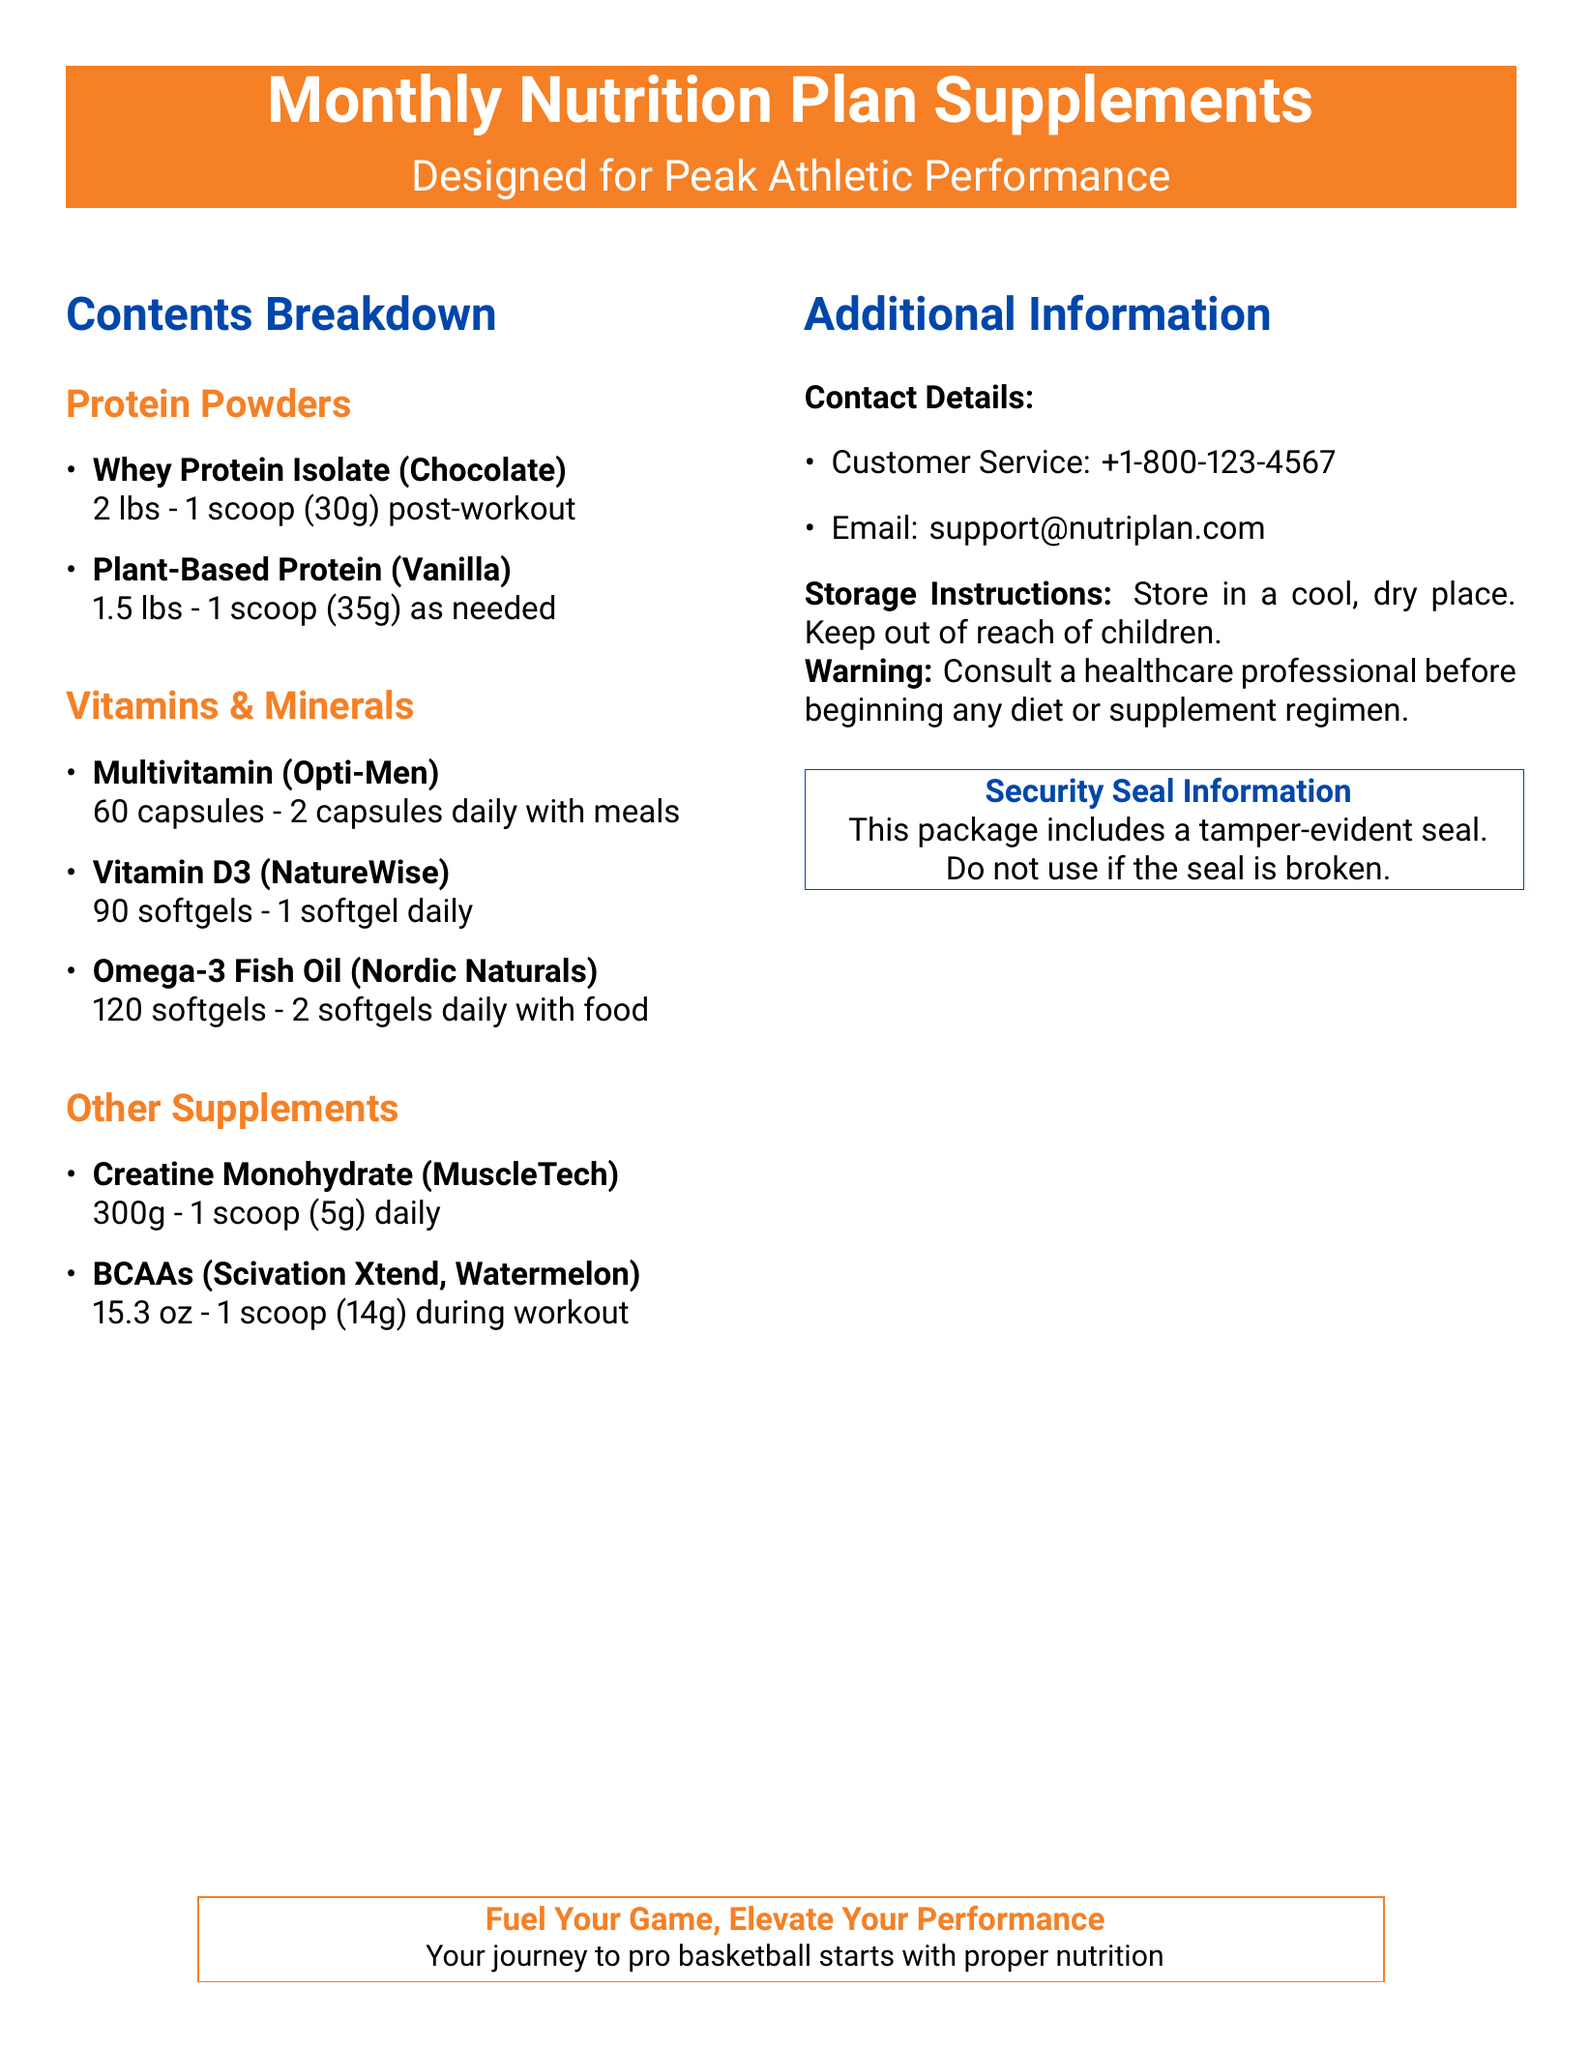What is the first protein powder listed? The first protein powder listed is Whey Protein Isolate (Chocolate).
Answer: Whey Protein Isolate (Chocolate) How many capsules of Multivitamin are included? The document states there are 60 capsules of Multivitamin (Opti-Men).
Answer: 60 capsules What is the daily dosage for Omega-3 Fish Oil? The daily dosage for Omega-3 Fish Oil is 2 softgels daily with food.
Answer: 2 softgels How many grams of Creatine Monohydrate are in the package? The document lists 300g of Creatine Monohydrate.
Answer: 300g What is the purpose of the security seal? The purpose of the security seal is to indicate tamper-evidence; if broken, do not use the package.
Answer: Tamper-evident Which vitamin is recommended to take daily aside from the multivitamin? Vitamin D3 (NatureWise) is recommended to be taken daily.
Answer: Vitamin D3 How many scoops of BCAAs should be taken during a workout? The label specifies to take 1 scoop (14g) of BCAAs during a workout.
Answer: 1 scoop What is the contact number for customer service? The customer service number listed is +1-800-123-4567.
Answer: +1-800-123-4567 Where should the supplements be stored? The storage instructions indicate to store in a cool, dry place.
Answer: Cool, dry place 